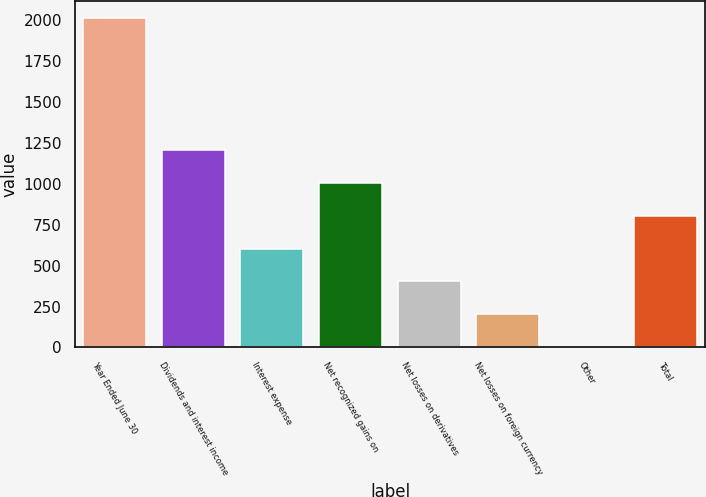Convert chart to OTSL. <chart><loc_0><loc_0><loc_500><loc_500><bar_chart><fcel>Year Ended June 30<fcel>Dividends and interest income<fcel>Interest expense<fcel>Net recognized gains on<fcel>Net losses on derivatives<fcel>Net losses on foreign currency<fcel>Other<fcel>Total<nl><fcel>2012<fcel>1207.6<fcel>604.3<fcel>1006.5<fcel>403.2<fcel>202.1<fcel>1<fcel>805.4<nl></chart> 